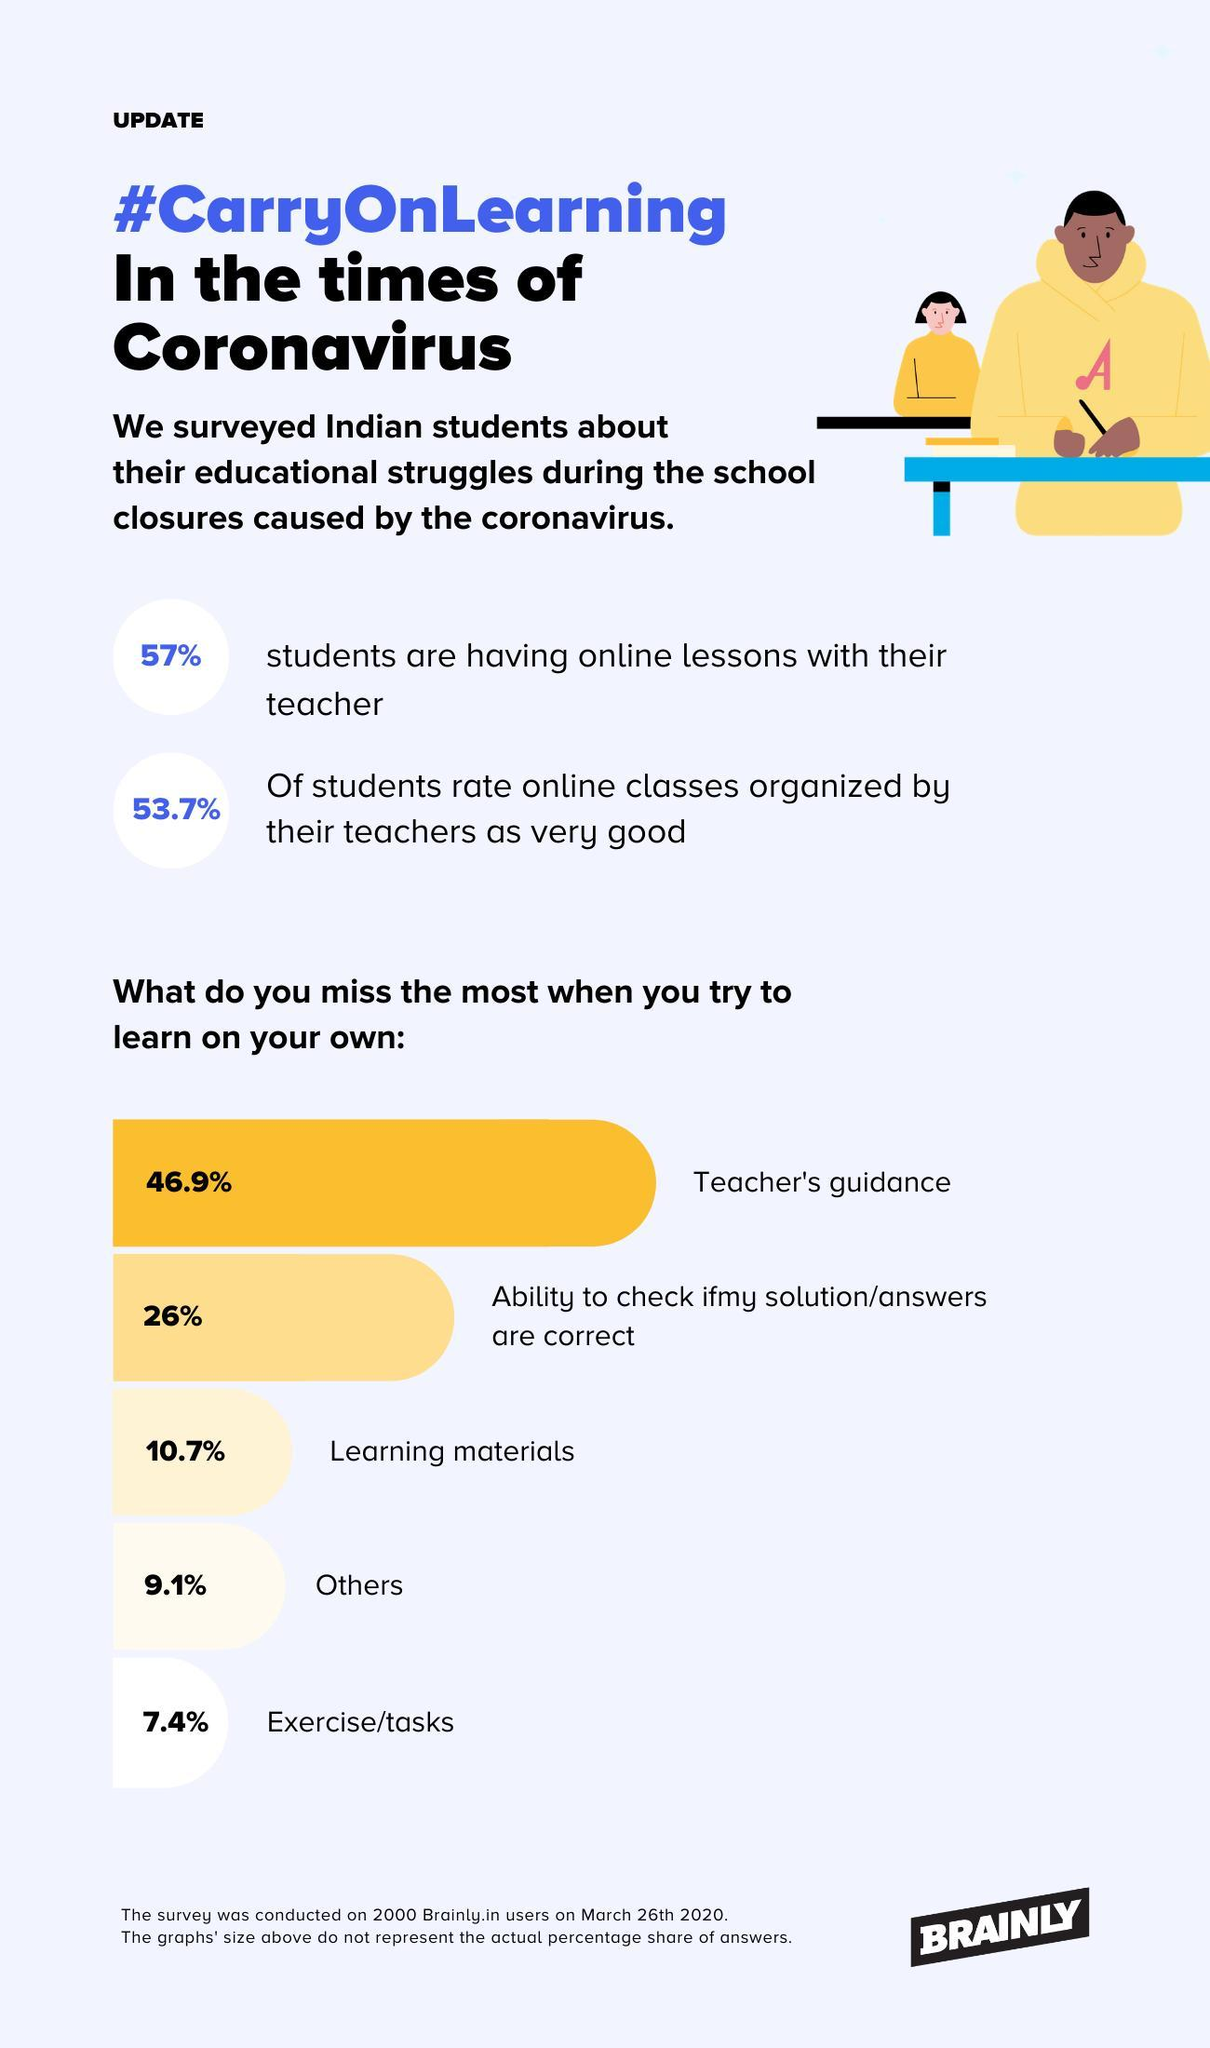What percentage of students did not miss the ability to check if their answers are correct?
Answer the question with a short phrase. 74% What percentage of students did not miss the teacher's guidance? 53.1% What percentage of students did not miss tasks? 92.6% What percentage of students are not having online lessons with their teachers? 43% What percentage of students did not miss learning materials? 89.3% 